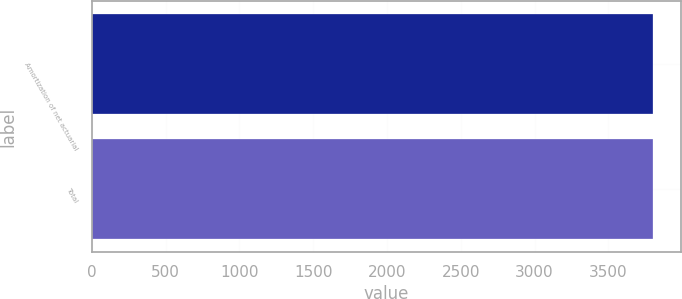<chart> <loc_0><loc_0><loc_500><loc_500><bar_chart><fcel>Amortization of net actuarial<fcel>Total<nl><fcel>3804<fcel>3804.1<nl></chart> 